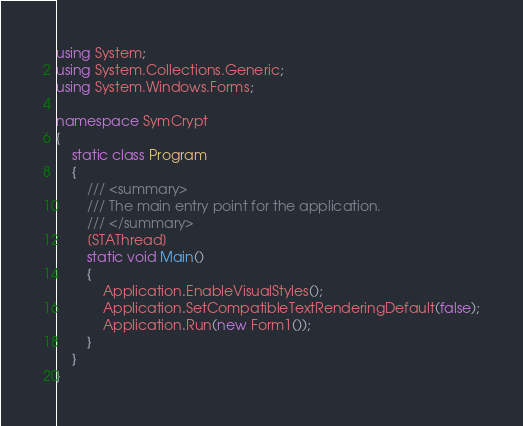Convert code to text. <code><loc_0><loc_0><loc_500><loc_500><_C#_>using System;
using System.Collections.Generic;
using System.Windows.Forms;

namespace SymCrypt
{
    static class Program
    {
        /// <summary>
        /// The main entry point for the application.
        /// </summary>
        [STAThread]
        static void Main()
        {
            Application.EnableVisualStyles();
            Application.SetCompatibleTextRenderingDefault(false);
            Application.Run(new Form1());
        }
    }
}</code> 